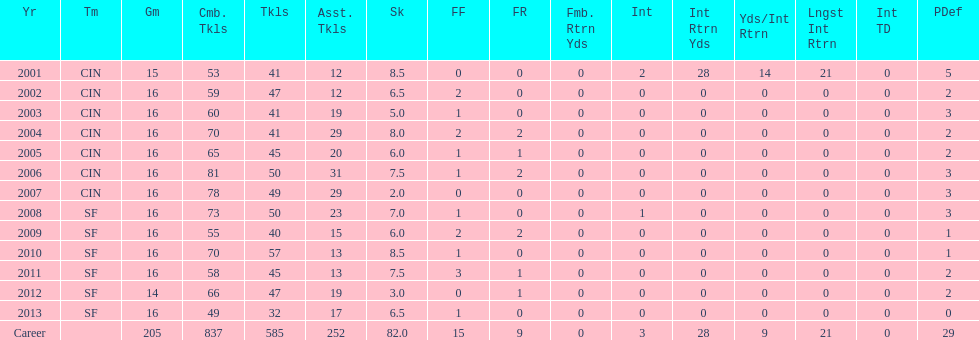What is the total number of sacks smith has made? 82.0. 